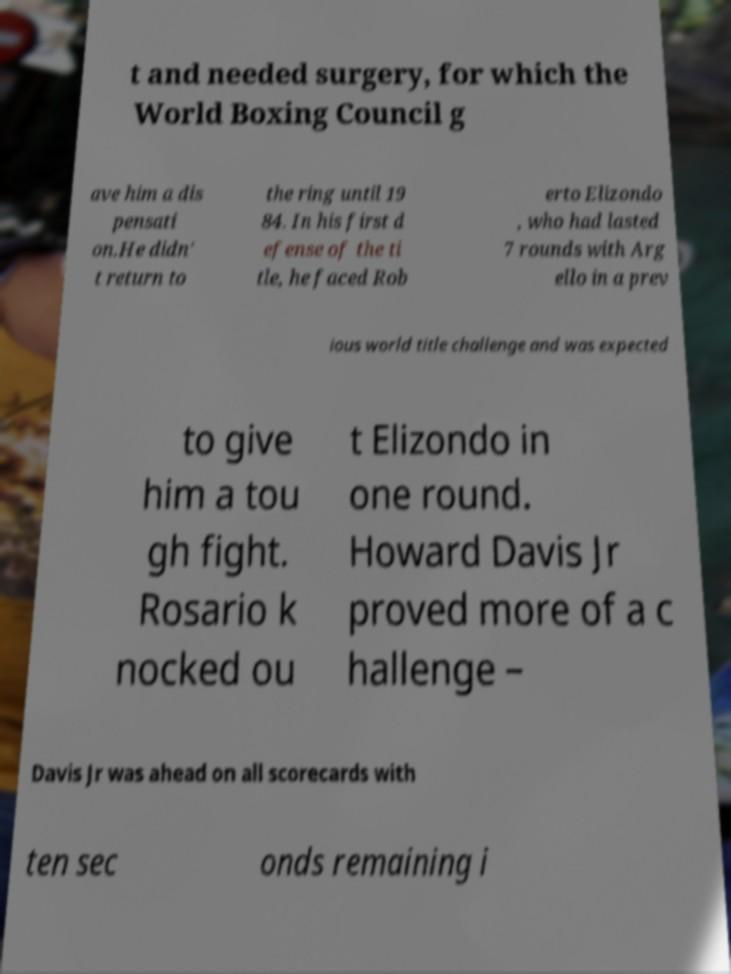There's text embedded in this image that I need extracted. Can you transcribe it verbatim? t and needed surgery, for which the World Boxing Council g ave him a dis pensati on.He didn' t return to the ring until 19 84. In his first d efense of the ti tle, he faced Rob erto Elizondo , who had lasted 7 rounds with Arg ello in a prev ious world title challenge and was expected to give him a tou gh fight. Rosario k nocked ou t Elizondo in one round. Howard Davis Jr proved more of a c hallenge – Davis Jr was ahead on all scorecards with ten sec onds remaining i 